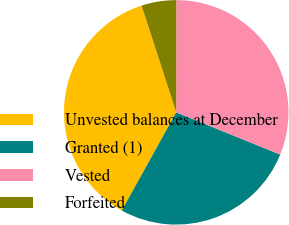Convert chart. <chart><loc_0><loc_0><loc_500><loc_500><pie_chart><fcel>Unvested balances at December<fcel>Granted (1)<fcel>Vested<fcel>Forfeited<nl><fcel>36.95%<fcel>26.92%<fcel>31.13%<fcel>5.0%<nl></chart> 